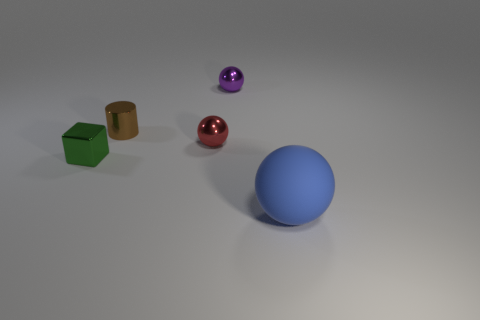Are there any other things that have the same size as the red metallic sphere?
Make the answer very short. Yes. Is the number of brown cylinders less than the number of yellow rubber spheres?
Provide a succinct answer. No. What shape is the object that is in front of the small red metal sphere and behind the big sphere?
Make the answer very short. Cube. What number of tiny yellow rubber cylinders are there?
Your answer should be very brief. 0. What is the material of the tiny sphere behind the small sphere in front of the metal object behind the small brown thing?
Your answer should be compact. Metal. There is a metallic ball that is in front of the cylinder; how many things are on the left side of it?
Your answer should be very brief. 2. The other tiny object that is the same shape as the small red shiny thing is what color?
Your response must be concise. Purple. Does the tiny brown cylinder have the same material as the big sphere?
Your response must be concise. No. What number of balls are either tiny blue metallic objects or blue matte things?
Provide a short and direct response. 1. What is the size of the ball right of the metallic sphere that is behind the sphere that is on the left side of the purple metallic thing?
Make the answer very short. Large. 